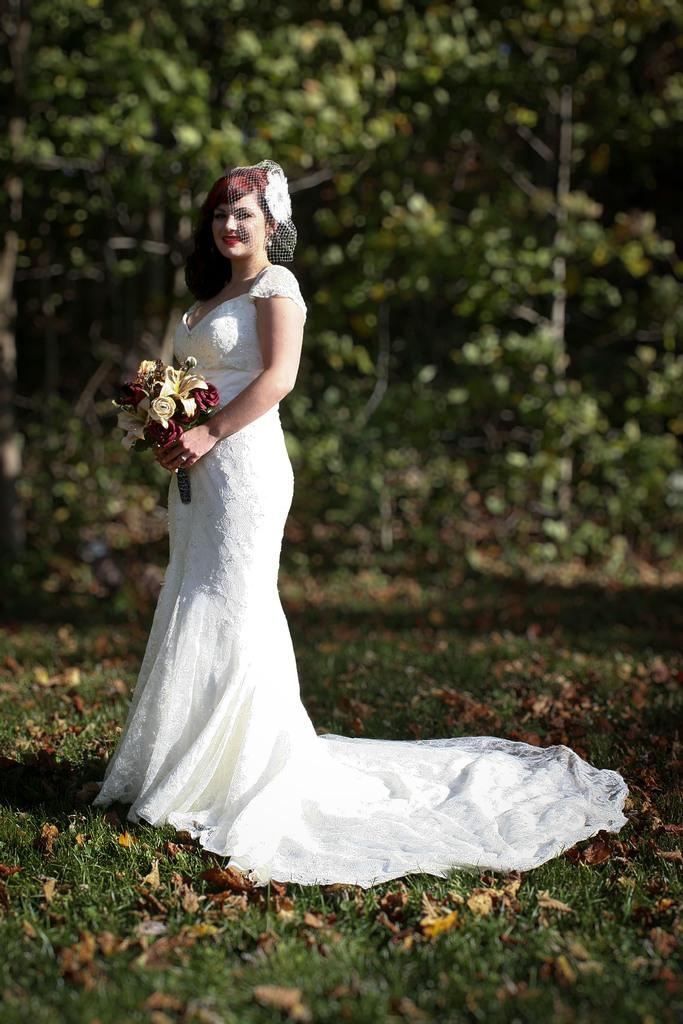Who is present in the image? There is a woman in the image. What is the woman wearing? The woman is wearing a wedding dress. What is the woman holding in the image? The woman is holding a flower bouquet. What type of natural environment is visible in the image? There is green grass and trees visible in the image. What type of yam is being used as an ornament on the woman's collar in the image? There is no yam or collar present in the image. The woman is wearing a wedding dress and holding a flower bouquet, but there is no mention of a yam ornament. 